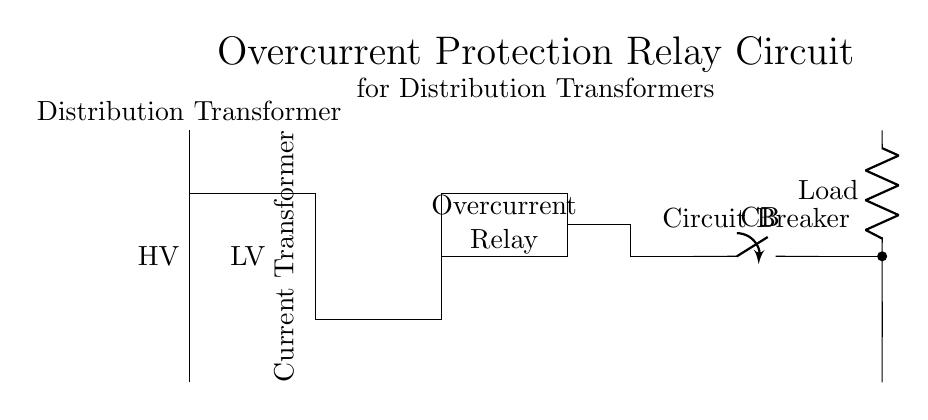What type of transformer is shown in the circuit? The circuit includes a distribution transformer, indicated in the diagram as the component labeled "Distribution Transformer" at the top.
Answer: Distribution Transformer What component is employed for current measurement? The circuit diagram shows a current transformer, labeled as "Current Transformer," which is responsible for measuring or sensing current.
Answer: Current Transformer What does the overcurrent relay do in this circuit? The overcurrent relay is designed to trip or interrupt the circuit when the current exceeds a predetermined threshold, protecting the system.
Answer: Trip What is the function of the circuit breaker? The circuit breaker operates as an automatic switch that opens the circuit when excessive current results in an overload or short circuit condition, thereby protecting the system.
Answer: Protects the circuit How are the load and transformer connected? The load is connected to the low voltage side of the transformer and appears as a resistor in series on the output side of the circuit.
Answer: Series connection What is the voltage designation indicated in the circuit? The high voltage (HV) designation is placed next to the distribution transformer, showing the input side, while the low voltage (LV) is marked on the output side.
Answer: High Voltage 